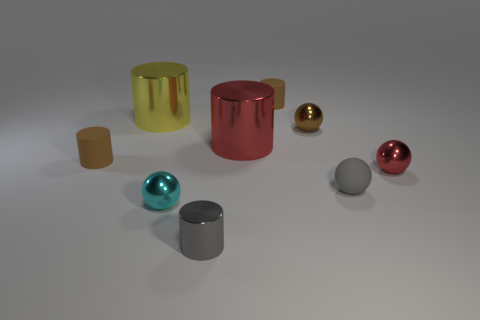Is the number of tiny blue objects greater than the number of tiny brown metal things?
Keep it short and to the point. No. Does the metal thing that is on the right side of the gray matte ball have the same color as the tiny shiny sphere behind the tiny red ball?
Provide a short and direct response. No. Are there any small gray metallic cylinders on the left side of the small brown cylinder that is to the left of the yellow cylinder?
Your answer should be very brief. No. Is the number of small brown rubber objects behind the big yellow metallic cylinder less than the number of yellow cylinders in front of the cyan ball?
Provide a short and direct response. No. Is the cylinder that is in front of the gray sphere made of the same material as the tiny object that is on the right side of the tiny gray matte sphere?
Your answer should be compact. Yes. How many big objects are either gray matte balls or cyan metal balls?
Offer a very short reply. 0. What is the shape of the tiny brown object that is the same material as the gray cylinder?
Give a very brief answer. Sphere. Are there fewer cylinders left of the large yellow shiny object than small brown cylinders?
Offer a terse response. Yes. Is the shape of the gray matte thing the same as the small red metal object?
Ensure brevity in your answer.  Yes. What number of shiny objects are tiny cyan spheres or red cylinders?
Your response must be concise. 2. 